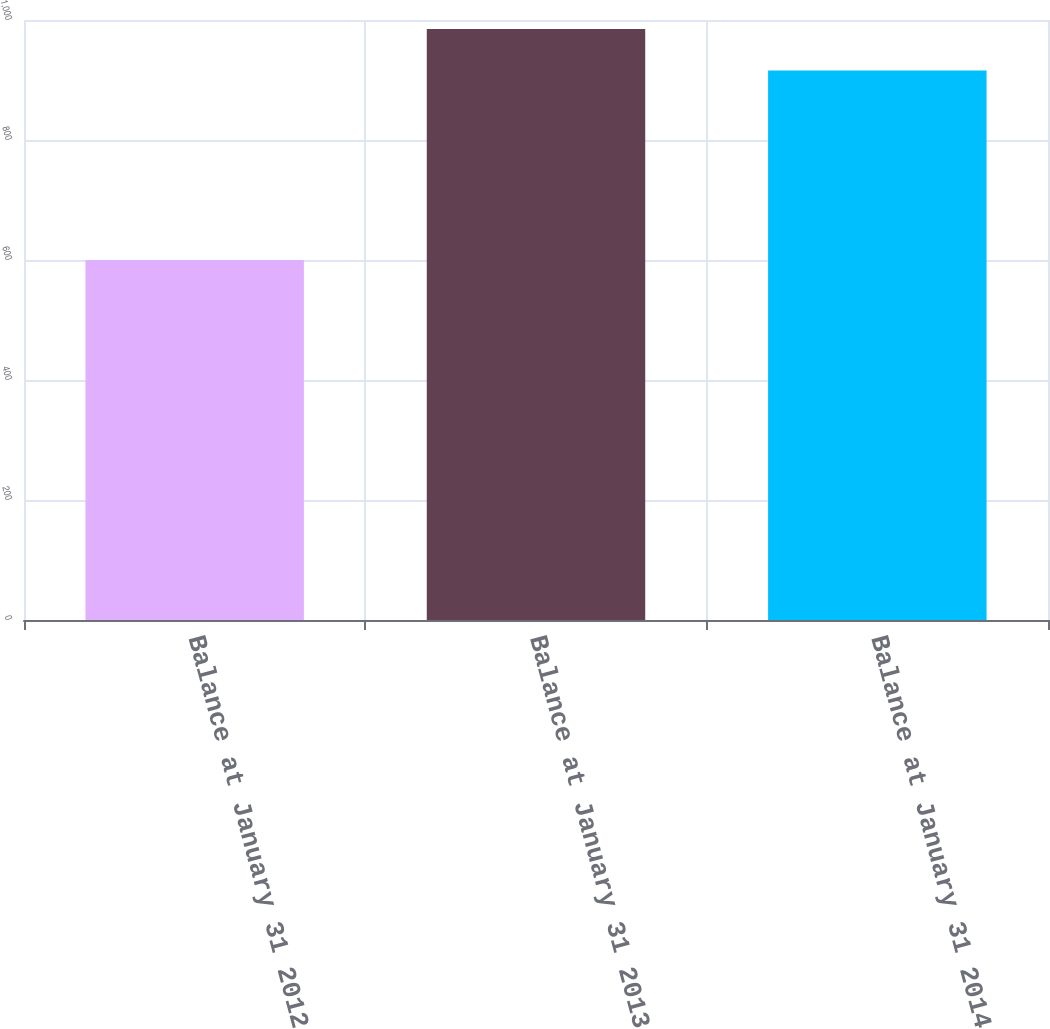Convert chart. <chart><loc_0><loc_0><loc_500><loc_500><bar_chart><fcel>Balance at January 31 2012<fcel>Balance at January 31 2013<fcel>Balance at January 31 2014<nl><fcel>600<fcel>985<fcel>916<nl></chart> 